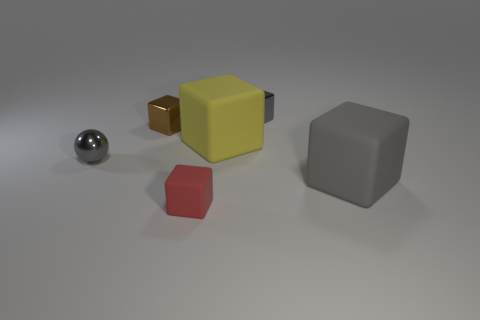There is a big object that is the same color as the shiny ball; what is its shape?
Offer a very short reply. Cube. Are the yellow object in front of the brown block and the small brown cube made of the same material?
Your answer should be very brief. No. What is the tiny thing right of the red matte thing on the right side of the small gray shiny sphere made of?
Your response must be concise. Metal. How many large blue metal things are the same shape as the small red matte object?
Offer a terse response. 0. There is a yellow matte cube that is on the right side of the small thing in front of the tiny gray metal object in front of the brown metal block; how big is it?
Your answer should be very brief. Large. How many red things are either rubber cubes or tiny rubber cubes?
Your answer should be compact. 1. There is a big matte thing in front of the metallic ball; is its shape the same as the red matte thing?
Provide a succinct answer. Yes. Are there more small rubber things that are left of the tiny gray shiny ball than green metallic balls?
Your response must be concise. No. What number of yellow cubes are the same size as the red object?
Offer a very short reply. 0. What size is the metallic cube that is the same color as the tiny ball?
Keep it short and to the point. Small. 